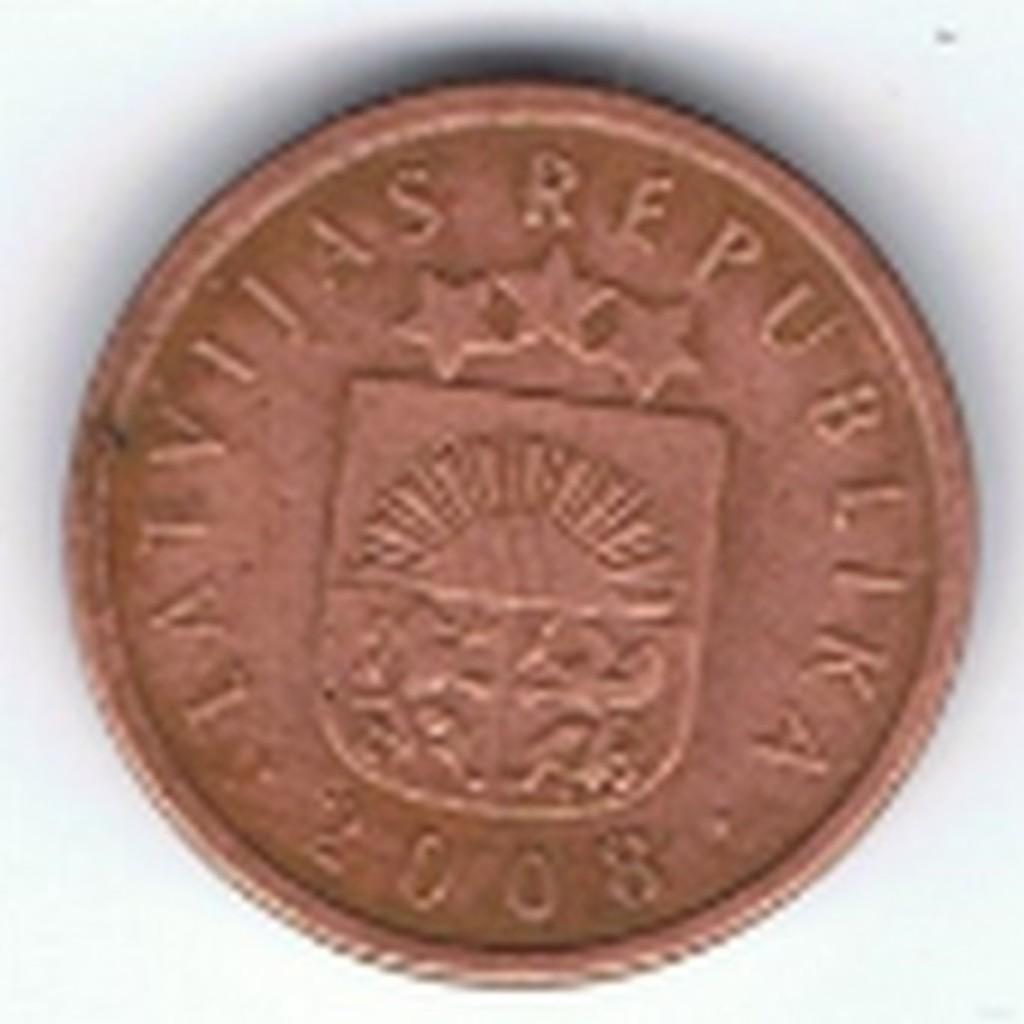<image>
Write a terse but informative summary of the picture. A very blurry picture of an latvijas republika 2008 coin 